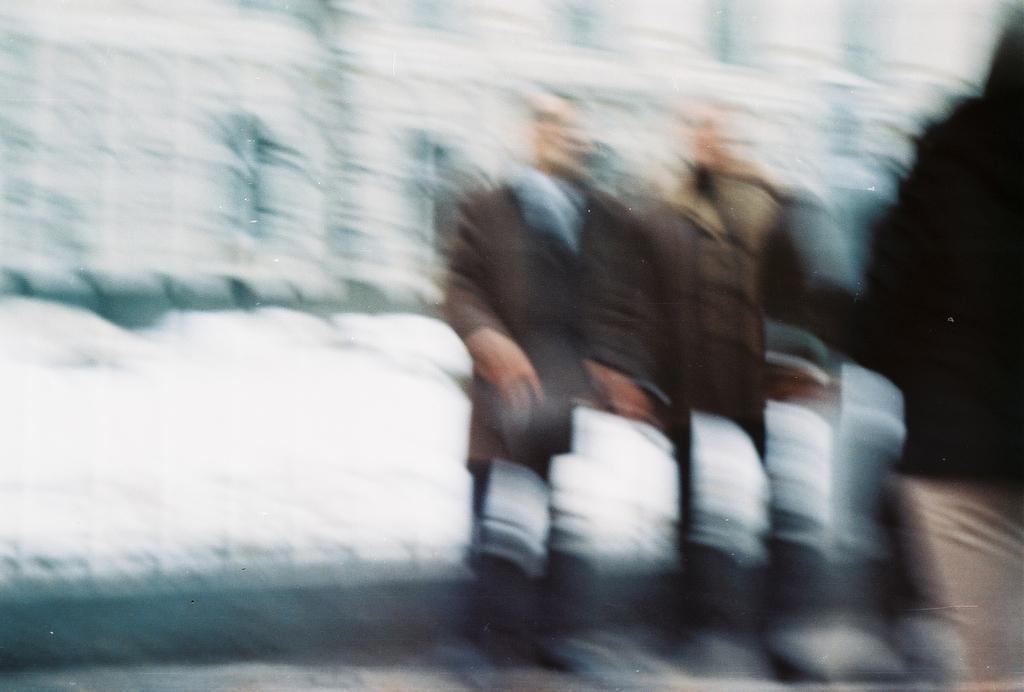How would you summarize this image in a sentence or two? It is a blurry image. In this image we can see people and snow. 